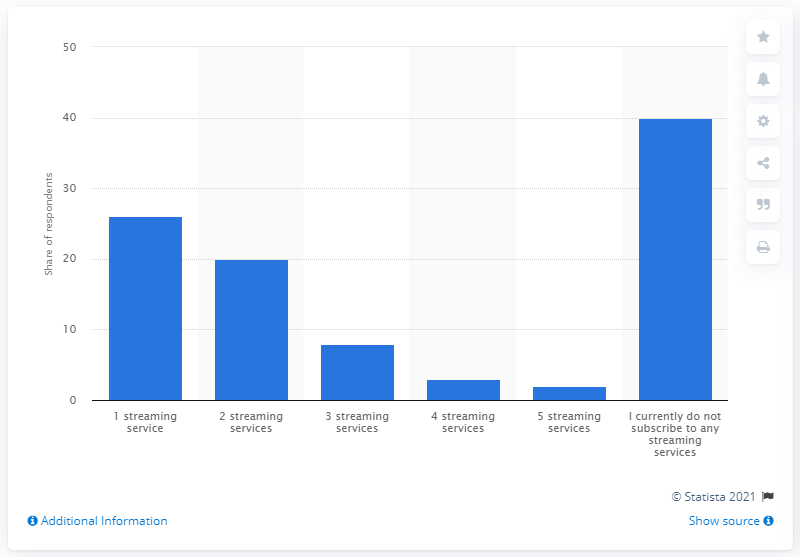Indicate a few pertinent items in this graphic. According to respondents, 20% of them stated that they currently hold a paid subscription to two or more streaming services. 